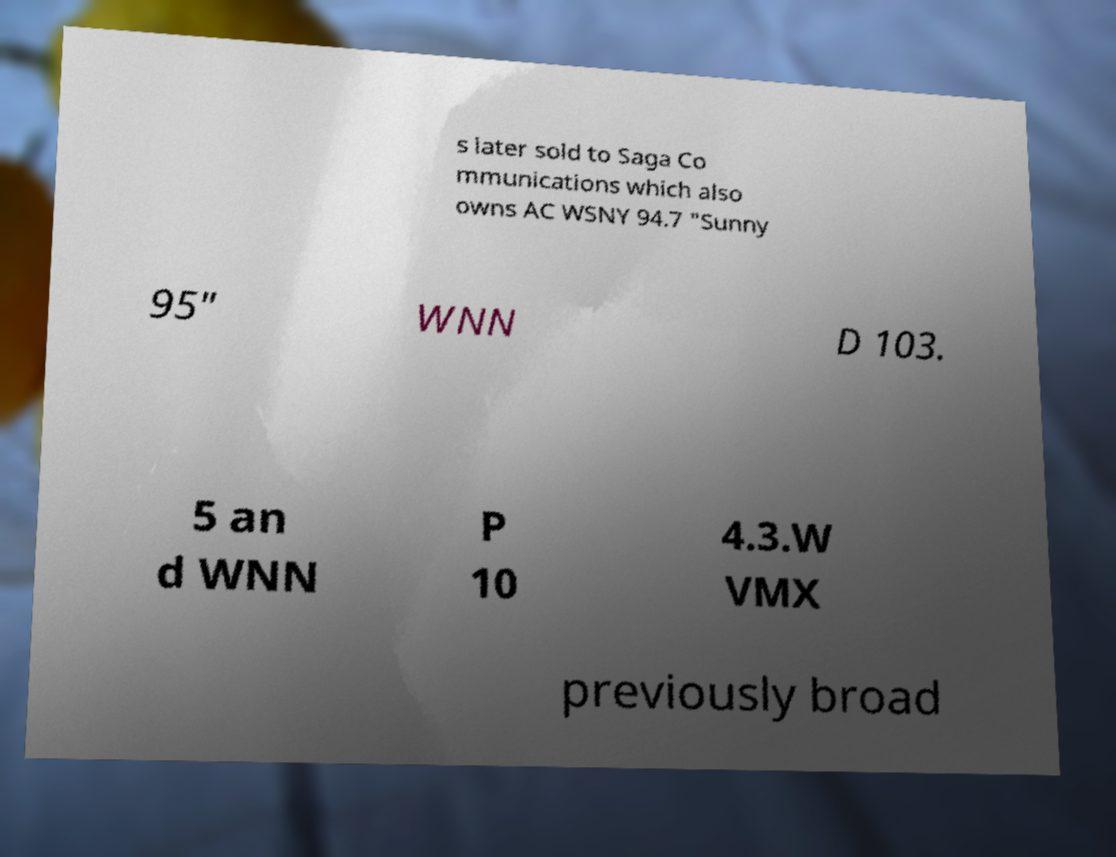Please identify and transcribe the text found in this image. s later sold to Saga Co mmunications which also owns AC WSNY 94.7 "Sunny 95" WNN D 103. 5 an d WNN P 10 4.3.W VMX previously broad 